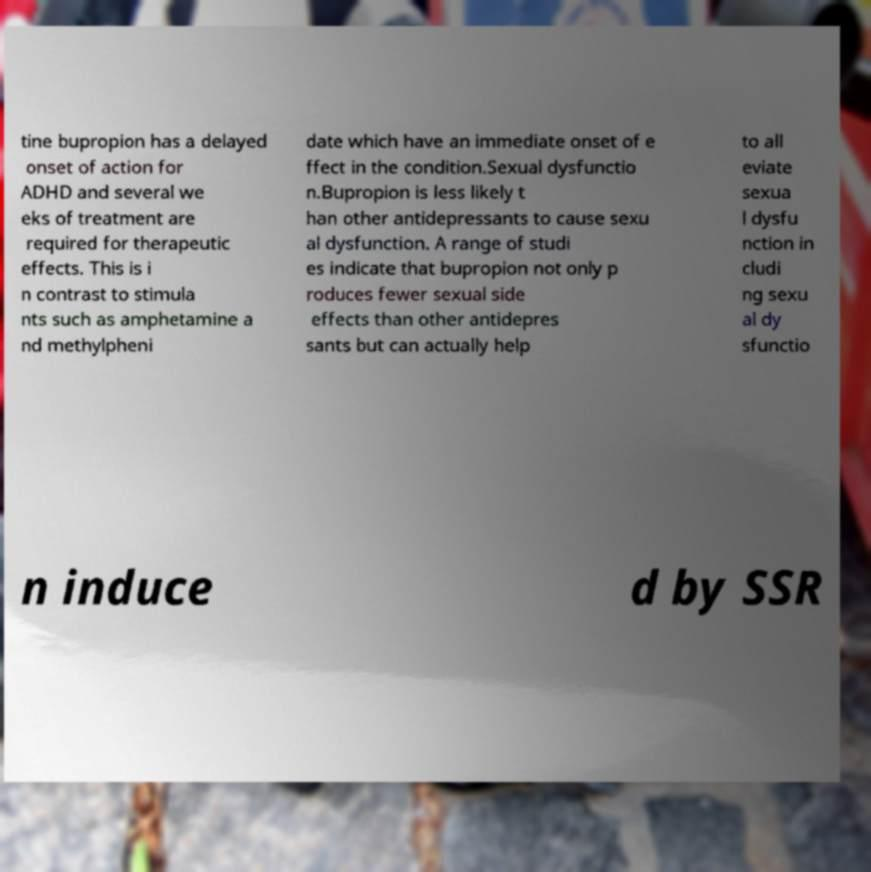Could you assist in decoding the text presented in this image and type it out clearly? tine bupropion has a delayed onset of action for ADHD and several we eks of treatment are required for therapeutic effects. This is i n contrast to stimula nts such as amphetamine a nd methylpheni date which have an immediate onset of e ffect in the condition.Sexual dysfunctio n.Bupropion is less likely t han other antidepressants to cause sexu al dysfunction. A range of studi es indicate that bupropion not only p roduces fewer sexual side effects than other antidepres sants but can actually help to all eviate sexua l dysfu nction in cludi ng sexu al dy sfunctio n induce d by SSR 